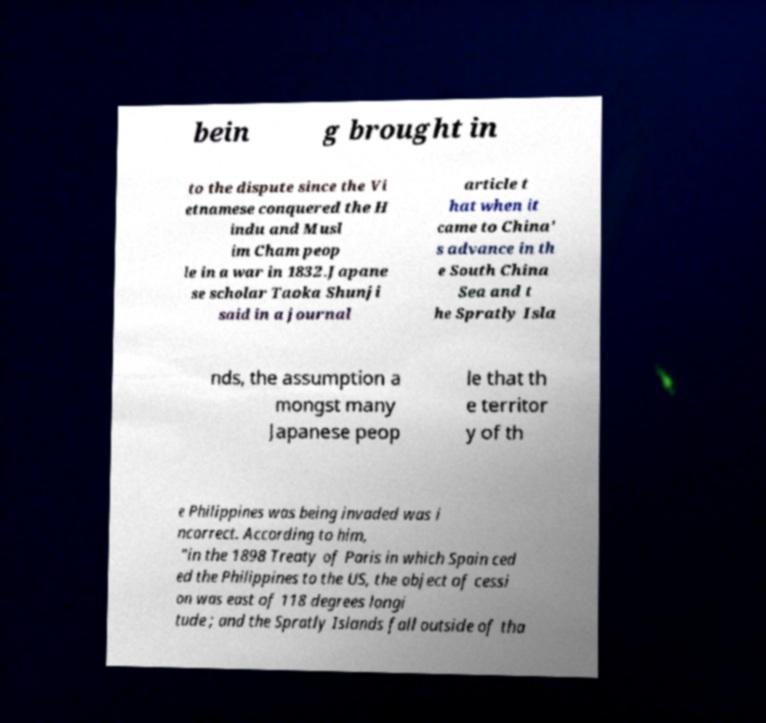There's text embedded in this image that I need extracted. Can you transcribe it verbatim? bein g brought in to the dispute since the Vi etnamese conquered the H indu and Musl im Cham peop le in a war in 1832.Japane se scholar Taoka Shunji said in a journal article t hat when it came to China’ s advance in th e South China Sea and t he Spratly Isla nds, the assumption a mongst many Japanese peop le that th e territor y of th e Philippines was being invaded was i ncorrect. According to him, "in the 1898 Treaty of Paris in which Spain ced ed the Philippines to the US, the object of cessi on was east of 118 degrees longi tude ; and the Spratly Islands fall outside of tha 